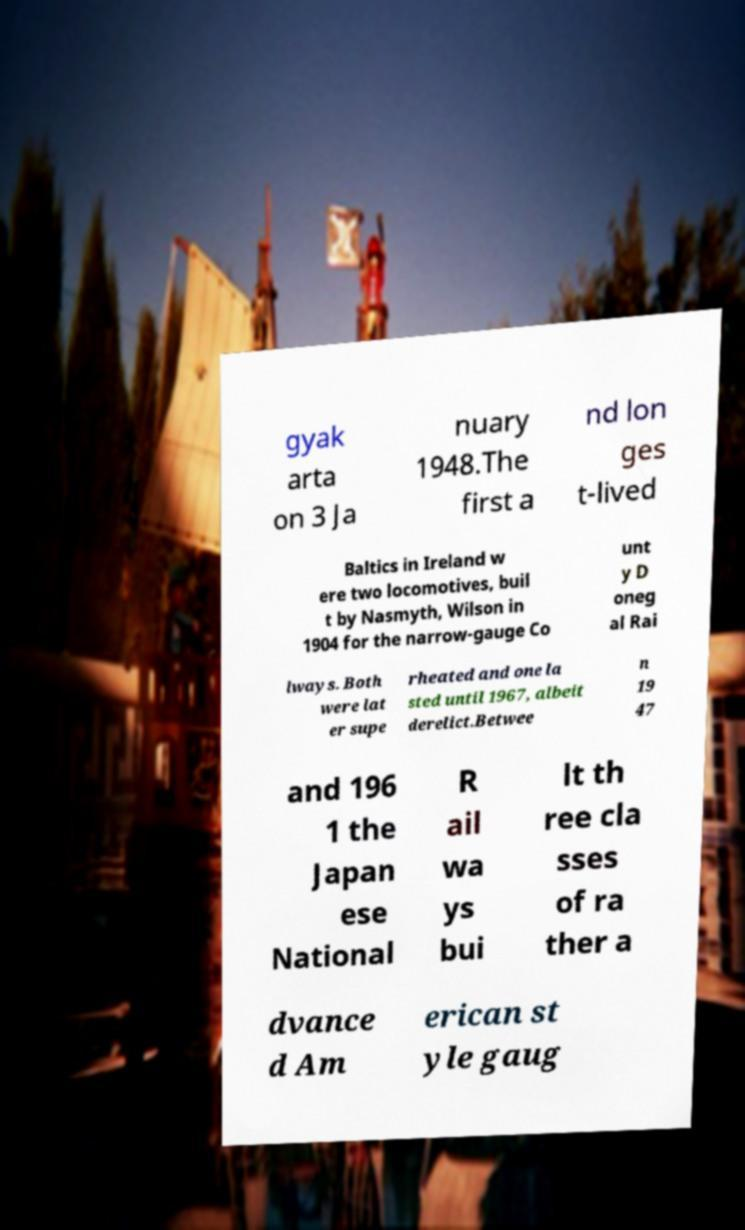What messages or text are displayed in this image? I need them in a readable, typed format. gyak arta on 3 Ja nuary 1948.The first a nd lon ges t-lived Baltics in Ireland w ere two locomotives, buil t by Nasmyth, Wilson in 1904 for the narrow-gauge Co unt y D oneg al Rai lways. Both were lat er supe rheated and one la sted until 1967, albeit derelict.Betwee n 19 47 and 196 1 the Japan ese National R ail wa ys bui lt th ree cla sses of ra ther a dvance d Am erican st yle gaug 